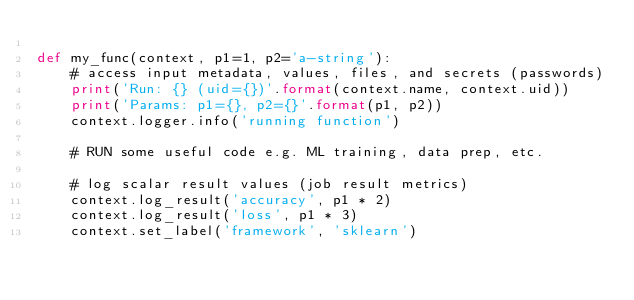Convert code to text. <code><loc_0><loc_0><loc_500><loc_500><_Python_>
def my_func(context, p1=1, p2='a-string'):
    # access input metadata, values, files, and secrets (passwords)
    print('Run: {} (uid={})'.format(context.name, context.uid))
    print('Params: p1={}, p2={}'.format(p1, p2))
    context.logger.info('running function')

    # RUN some useful code e.g. ML training, data prep, etc.

    # log scalar result values (job result metrics)
    context.log_result('accuracy', p1 * 2)
    context.log_result('loss', p1 * 3)
    context.set_label('framework', 'sklearn')

</code> 